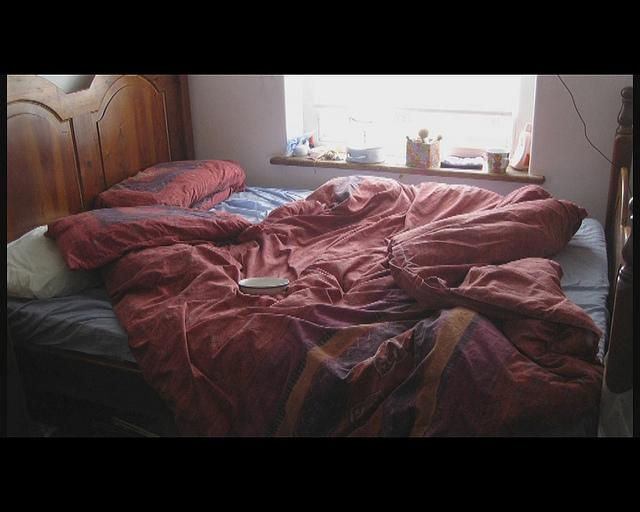Are there objects on the window seal?
Be succinct. Yes. Is the quilt primarily one color?
Give a very brief answer. Yes. What is red on bed?
Quick response, please. Blanket. Is the bed neat?
Keep it brief. No. Does the pillow match the bedspread?
Answer briefly. Yes. Is someone sleeping under the blanket?
Short answer required. No. Why is the room so messy?
Write a very short answer. Person is lazy. What design is on the blanket?
Quick response, please. Stripes. Is this your bed in the morning?
Give a very brief answer. Yes. 